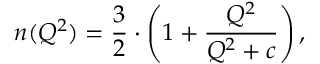Convert formula to latex. <formula><loc_0><loc_0><loc_500><loc_500>n ( Q ^ { 2 } ) = { \frac { 3 } { 2 } } \cdot \left ( 1 + { \frac { Q ^ { 2 } } { Q ^ { 2 } + c } } \right ) ,</formula> 